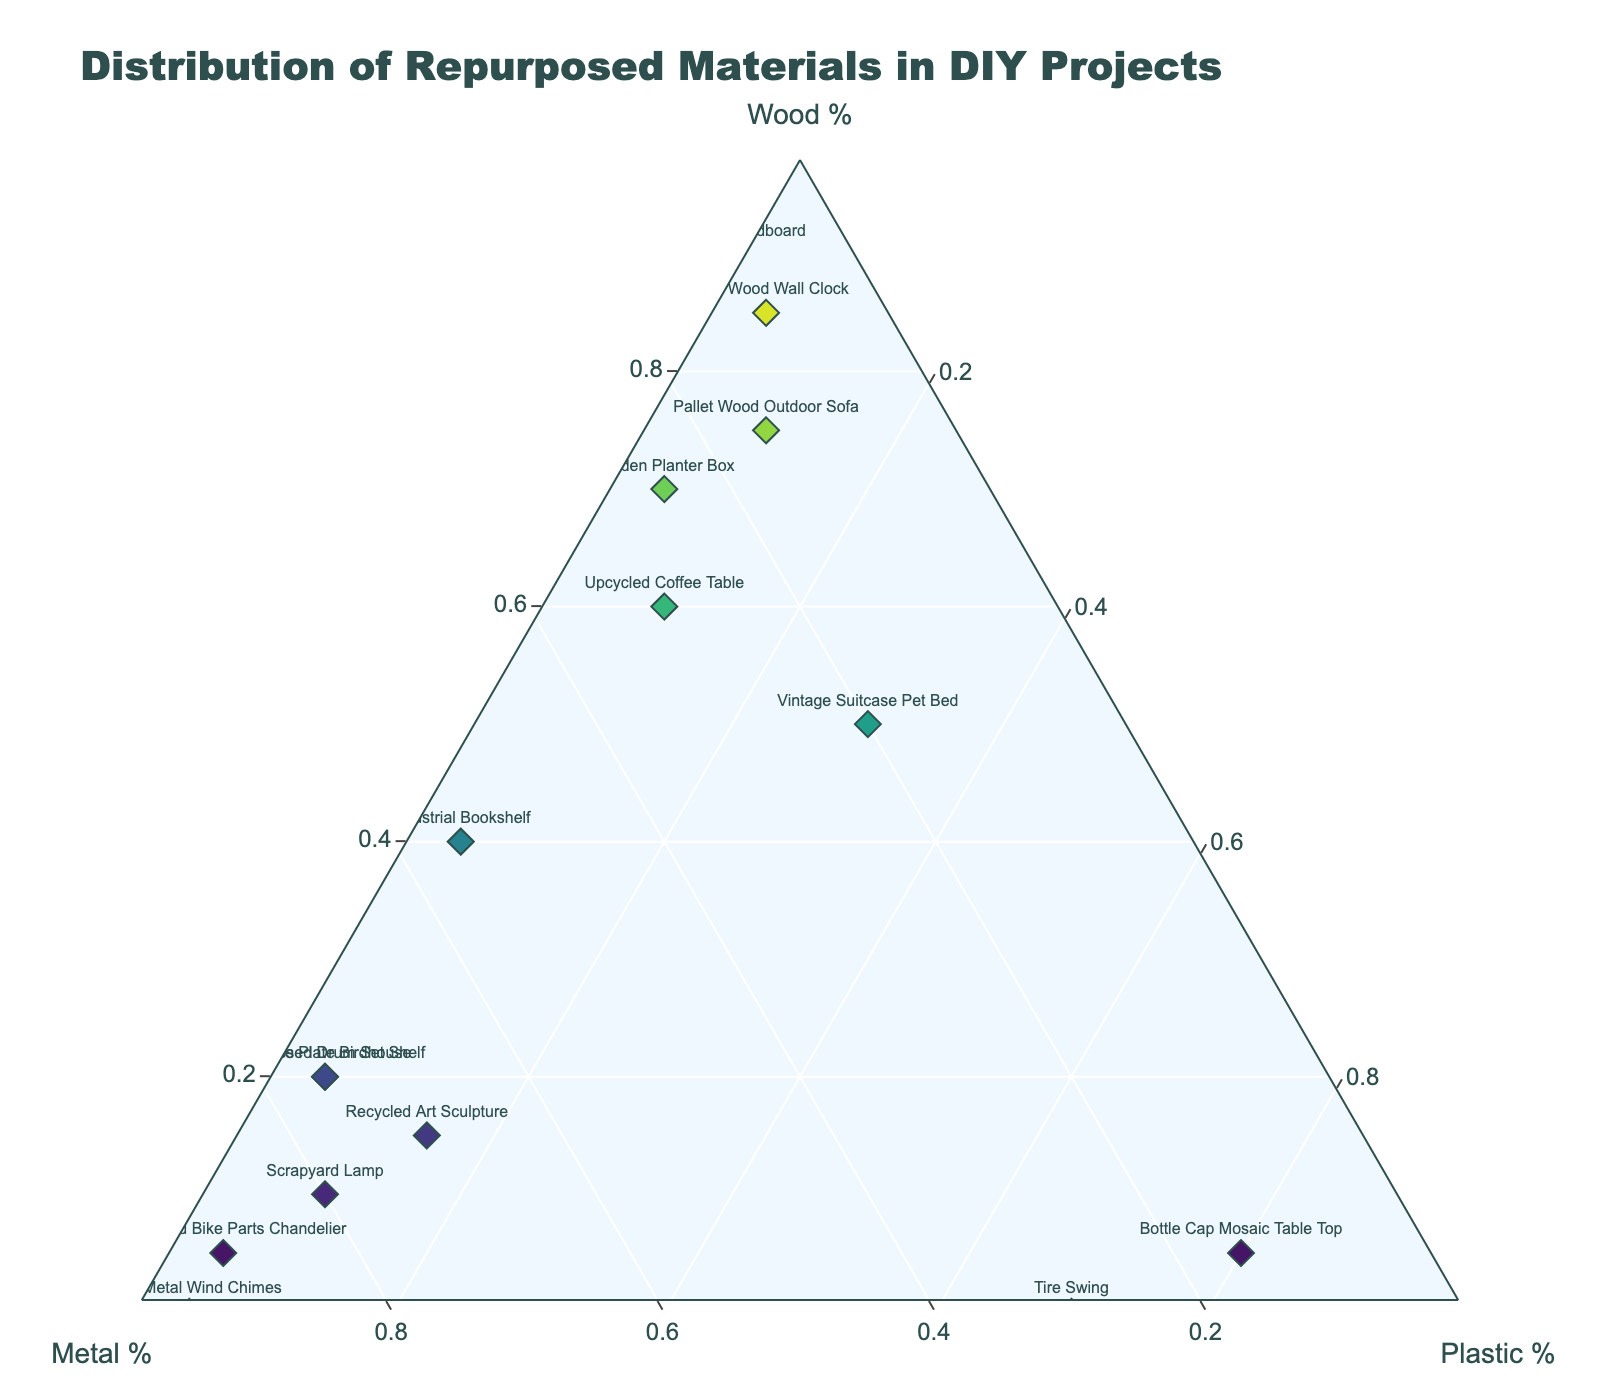What is the title of the plot? The title is located at the top of the plot and gives an overview of what the plot represents. By looking at the topmost area of the figure, we can find the main title.
Answer: Distribution of Repurposed Materials in DIY Projects How many projects use at least 70% Wood? Identify all data points (projects) where the Wood percentage is 70% or higher by looking at the axis labeled 'Wood' and count them. Projects: Garden Planter Box (70%), Pallet Wood Wall Clock (85%), Pallet Wood Outdoor Sofa (75%), Old Door Headboard (90%).
Answer: 4 Which project has the highest percentage of Metal and what is that percentage? Locate the data point closest to the 'Metal' axis at the vertex (apex of the triangle) which represents 100% Metal. The 'Repurposed Bike Parts Chandelier' is closest to that point. The table confirms it has 90% Metal.
Answer: Repurposed Bike Parts Chandelier, 90% What is the sum of the Wood percentages for the projects 'Upcycled Coffee Table' and 'Pallet Wood Wall Clock'? Find the Wood percentage for each project: 'Upcycled Coffee Table' (60%) and 'Pallet Wood Wall Clock' (85%). The sum is calculated by adding these percentages together.
Answer: 145% Of all the projects that use 5% or less Plastic, which one uses the most Metal? First, determine projects with 5% or less Plastic: Garden Planter Box (5%), Industrial Bookshelf (5%), Pallet Wood Wall Clock (5%), Repurposed Bike Parts Chandelier (5%), Scrap Metal Wind Chimes (5%), License Plate Birdhouse (5%), Repurposed Drum Set Shelf (5%). Compare their Metal percentages and find the highest value: Repurposed Bike Parts Chandelier (90%).
Answer: Repurposed Bike Parts Chandelier What’s the median percentage of Metal used across all projects? List all Metal percentages: 30, 80, 25, 55, 70, 10, 90, 20, 95, 30, 15, 75, 15, 10, 75. Arrange them in ascending order: 10, 10, 15, 15, 20, 25, 30, 30, 55, 70, 75, 75, 80, 90, 95. The median value in an ordered list of 15 elements is the 8th value (30).
Answer: 30% Which two projects share the exact same material composition percentages (Wood, Metal, Plastic)? Compare the percentage compositions of all projects. 'License Plate Birdhouse' and 'Repurposed Drum Set Shelf' both have 20% Wood, 75% Metal, and 5% Plastic.
Answer: License Plate Birdhouse and Repurposed Drum Set Shelf For the ‘Bottle Cap Mosaic Table Top’ project, what is the combined percentage of Wood and Metal? Identify the percentages of Wood (5%) and Metal (15%) for the project. Add these two values together.
Answer: 20% Which project is closest to having a balanced composition of the three materials? A balanced composition means having roughly equal percentages of Wood, Metal, and Plastic. By visually inspecting the plot, 'Vintage Suitcase Pet Bed' (50% Wood, 20% Metal, 30% Plastic) is the closest to balanced.
Answer: Vintage Suitcase Pet Bed 